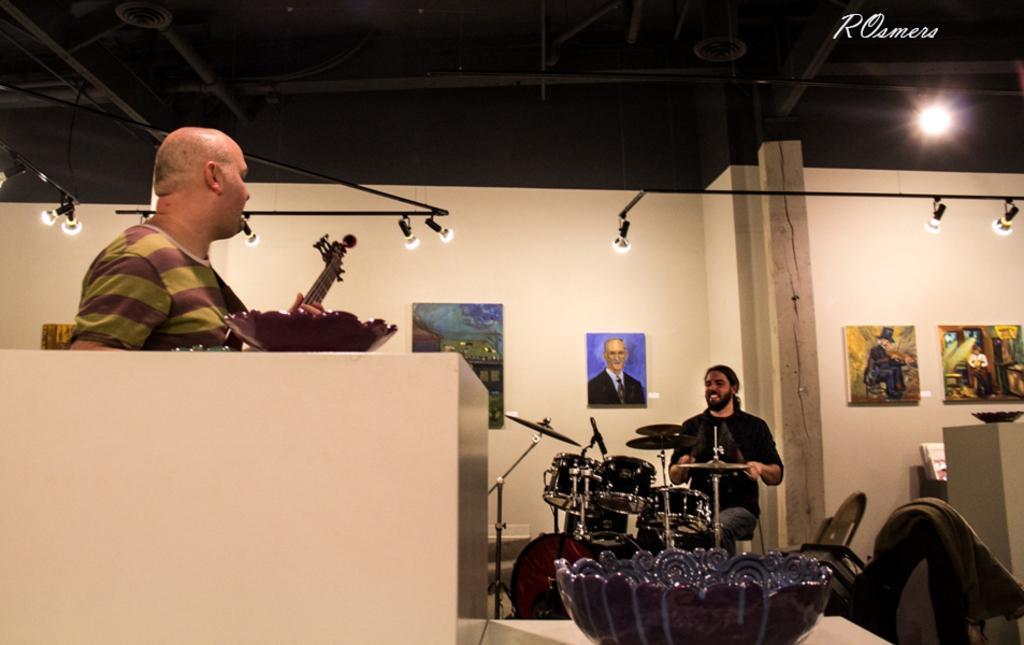In one or two sentences, can you explain what this image depicts? This is the picture of the inside of the room. On the right side we have a person. His sitting. His smiling. His playing drums. On the left side we have a another person. His playing guitar. We can see in the background there is a lighting,wall and photo frames. 